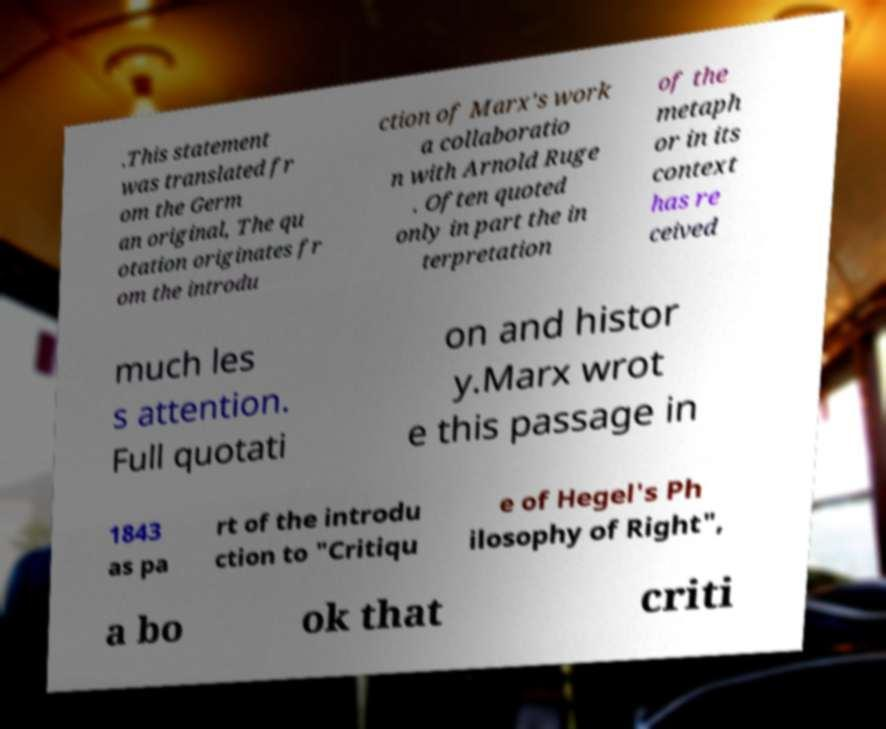Can you read and provide the text displayed in the image?This photo seems to have some interesting text. Can you extract and type it out for me? .This statement was translated fr om the Germ an original, The qu otation originates fr om the introdu ction of Marx's work a collaboratio n with Arnold Ruge . Often quoted only in part the in terpretation of the metaph or in its context has re ceived much les s attention. Full quotati on and histor y.Marx wrot e this passage in 1843 as pa rt of the introdu ction to "Critiqu e of Hegel's Ph ilosophy of Right", a bo ok that criti 